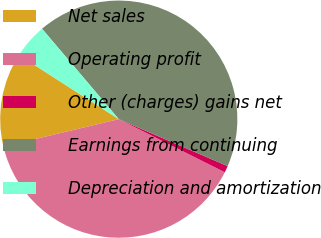Convert chart to OTSL. <chart><loc_0><loc_0><loc_500><loc_500><pie_chart><fcel>Net sales<fcel>Operating profit<fcel>Other (charges) gains net<fcel>Earnings from continuing<fcel>Depreciation and amortization<nl><fcel>12.81%<fcel>38.88%<fcel>0.91%<fcel>42.68%<fcel>4.71%<nl></chart> 